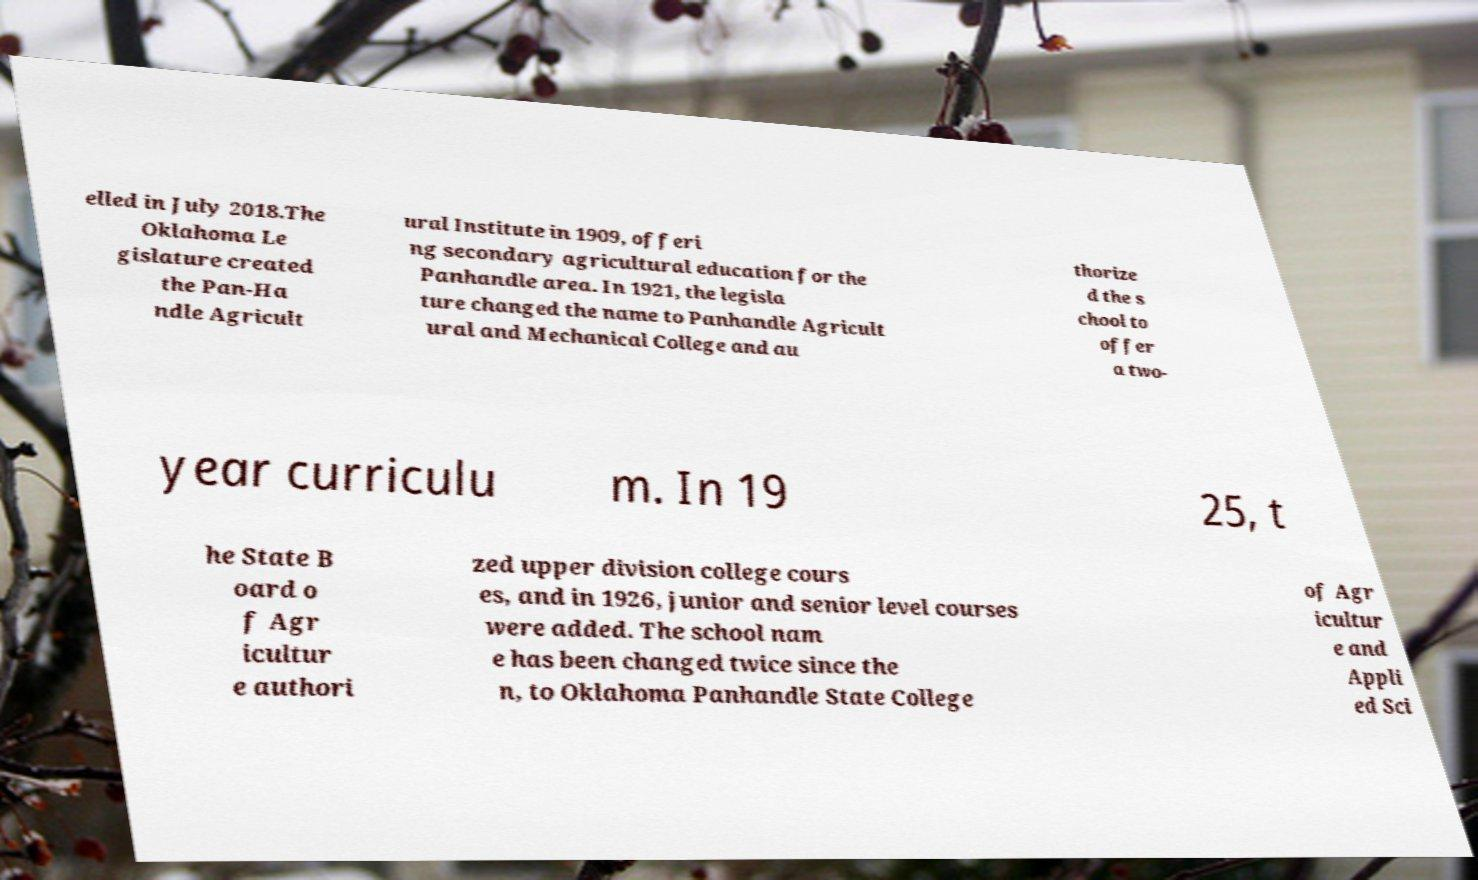Can you accurately transcribe the text from the provided image for me? elled in July 2018.The Oklahoma Le gislature created the Pan-Ha ndle Agricult ural Institute in 1909, offeri ng secondary agricultural education for the Panhandle area. In 1921, the legisla ture changed the name to Panhandle Agricult ural and Mechanical College and au thorize d the s chool to offer a two- year curriculu m. In 19 25, t he State B oard o f Agr icultur e authori zed upper division college cours es, and in 1926, junior and senior level courses were added. The school nam e has been changed twice since the n, to Oklahoma Panhandle State College of Agr icultur e and Appli ed Sci 